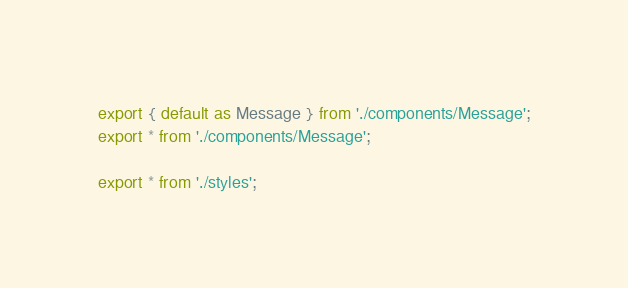Convert code to text. <code><loc_0><loc_0><loc_500><loc_500><_TypeScript_>export { default as Message } from './components/Message';
export * from './components/Message';

export * from './styles';
</code> 